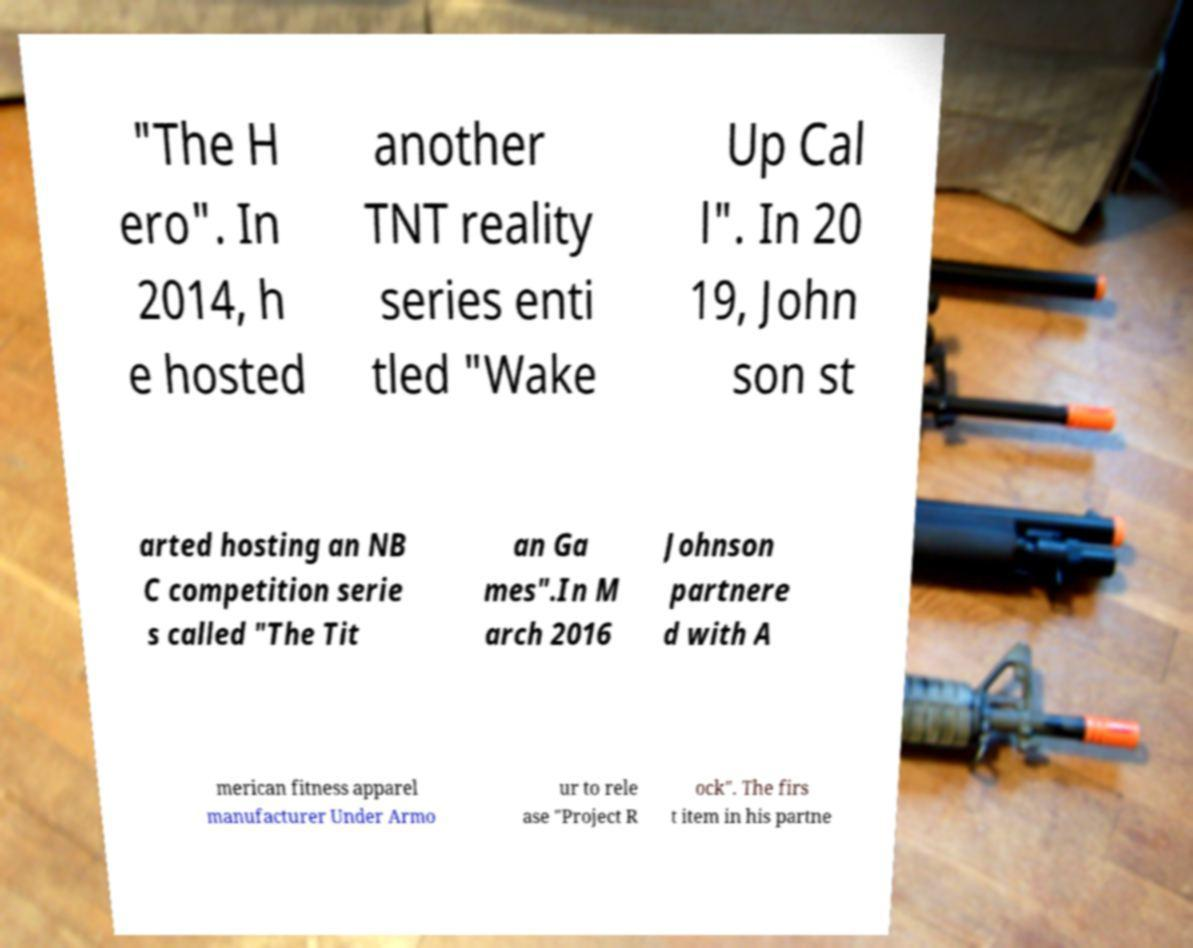Please identify and transcribe the text found in this image. "The H ero". In 2014, h e hosted another TNT reality series enti tled "Wake Up Cal l". In 20 19, John son st arted hosting an NB C competition serie s called "The Tit an Ga mes".In M arch 2016 Johnson partnere d with A merican fitness apparel manufacturer Under Armo ur to rele ase "Project R ock". The firs t item in his partne 